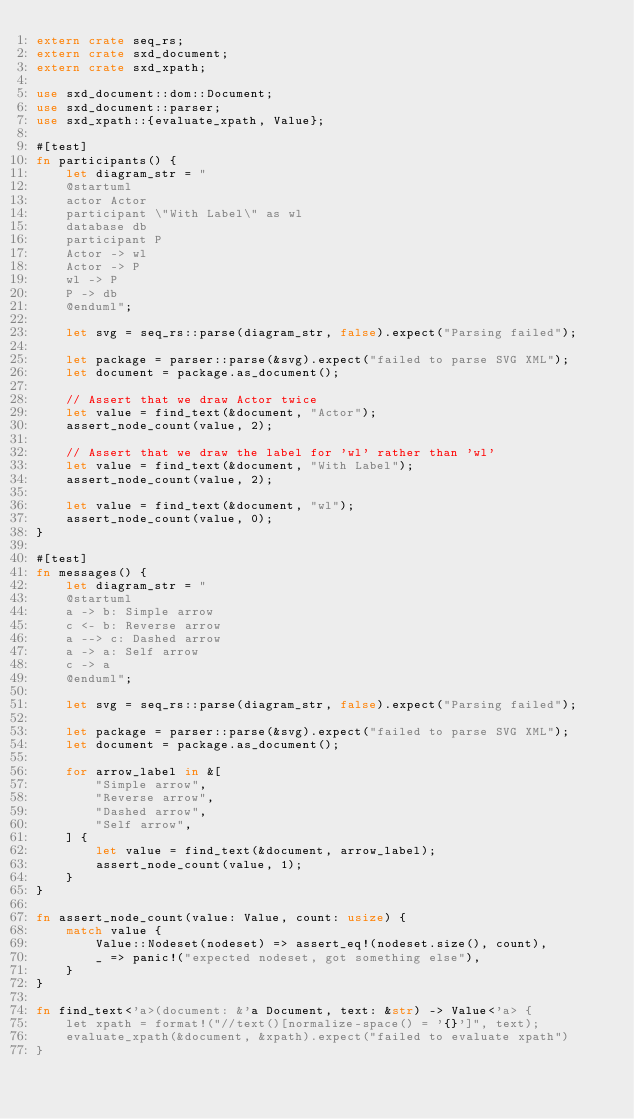Convert code to text. <code><loc_0><loc_0><loc_500><loc_500><_Rust_>extern crate seq_rs;
extern crate sxd_document;
extern crate sxd_xpath;

use sxd_document::dom::Document;
use sxd_document::parser;
use sxd_xpath::{evaluate_xpath, Value};

#[test]
fn participants() {
    let diagram_str = "
    @startuml
    actor Actor
    participant \"With Label\" as wl
    database db
    participant P
    Actor -> wl
    Actor -> P
    wl -> P
    P -> db
    @enduml";

    let svg = seq_rs::parse(diagram_str, false).expect("Parsing failed");

    let package = parser::parse(&svg).expect("failed to parse SVG XML");
    let document = package.as_document();

    // Assert that we draw Actor twice
    let value = find_text(&document, "Actor");
    assert_node_count(value, 2);

    // Assert that we draw the label for 'wl' rather than 'wl'
    let value = find_text(&document, "With Label");
    assert_node_count(value, 2);

    let value = find_text(&document, "wl");
    assert_node_count(value, 0);
}

#[test]
fn messages() {
    let diagram_str = "
    @startuml
    a -> b: Simple arrow
    c <- b: Reverse arrow
    a --> c: Dashed arrow
    a -> a: Self arrow
    c -> a
    @enduml";

    let svg = seq_rs::parse(diagram_str, false).expect("Parsing failed");

    let package = parser::parse(&svg).expect("failed to parse SVG XML");
    let document = package.as_document();

    for arrow_label in &[
        "Simple arrow",
        "Reverse arrow",
        "Dashed arrow",
        "Self arrow",
    ] {
        let value = find_text(&document, arrow_label);
        assert_node_count(value, 1);
    }
}

fn assert_node_count(value: Value, count: usize) {
    match value {
        Value::Nodeset(nodeset) => assert_eq!(nodeset.size(), count),
        _ => panic!("expected nodeset, got something else"),
    }
}

fn find_text<'a>(document: &'a Document, text: &str) -> Value<'a> {
    let xpath = format!("//text()[normalize-space() = '{}']", text);
    evaluate_xpath(&document, &xpath).expect("failed to evaluate xpath")
}
</code> 